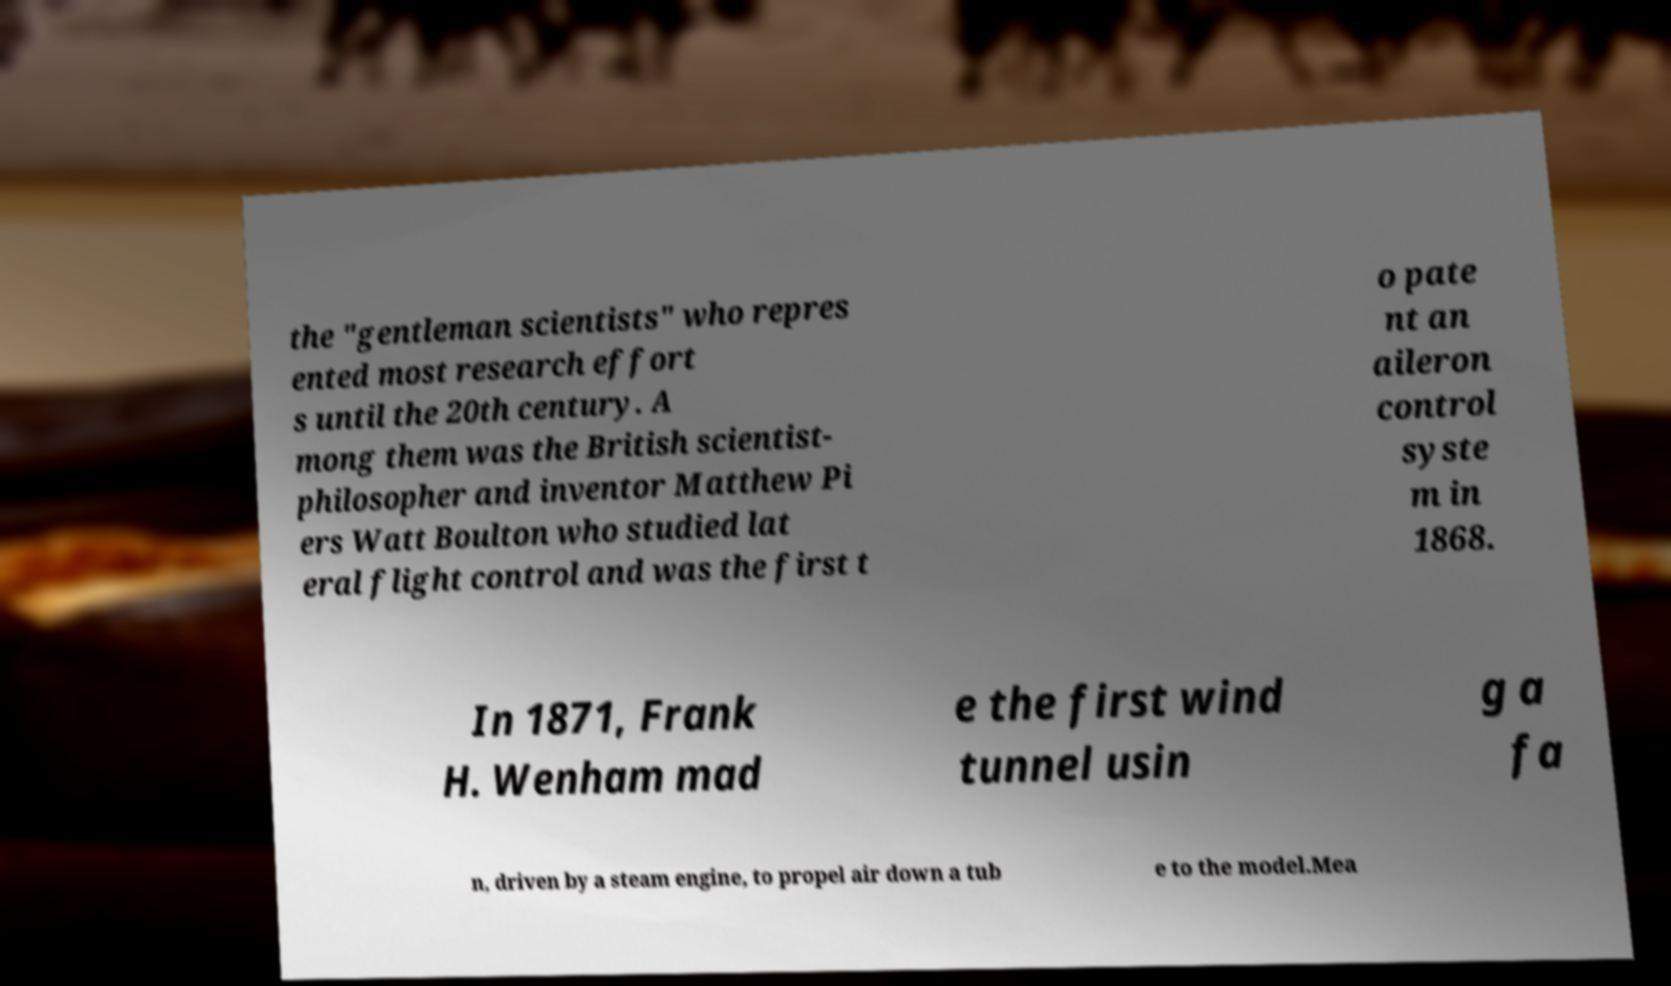What messages or text are displayed in this image? I need them in a readable, typed format. the "gentleman scientists" who repres ented most research effort s until the 20th century. A mong them was the British scientist- philosopher and inventor Matthew Pi ers Watt Boulton who studied lat eral flight control and was the first t o pate nt an aileron control syste m in 1868. In 1871, Frank H. Wenham mad e the first wind tunnel usin g a fa n, driven by a steam engine, to propel air down a tub e to the model.Mea 